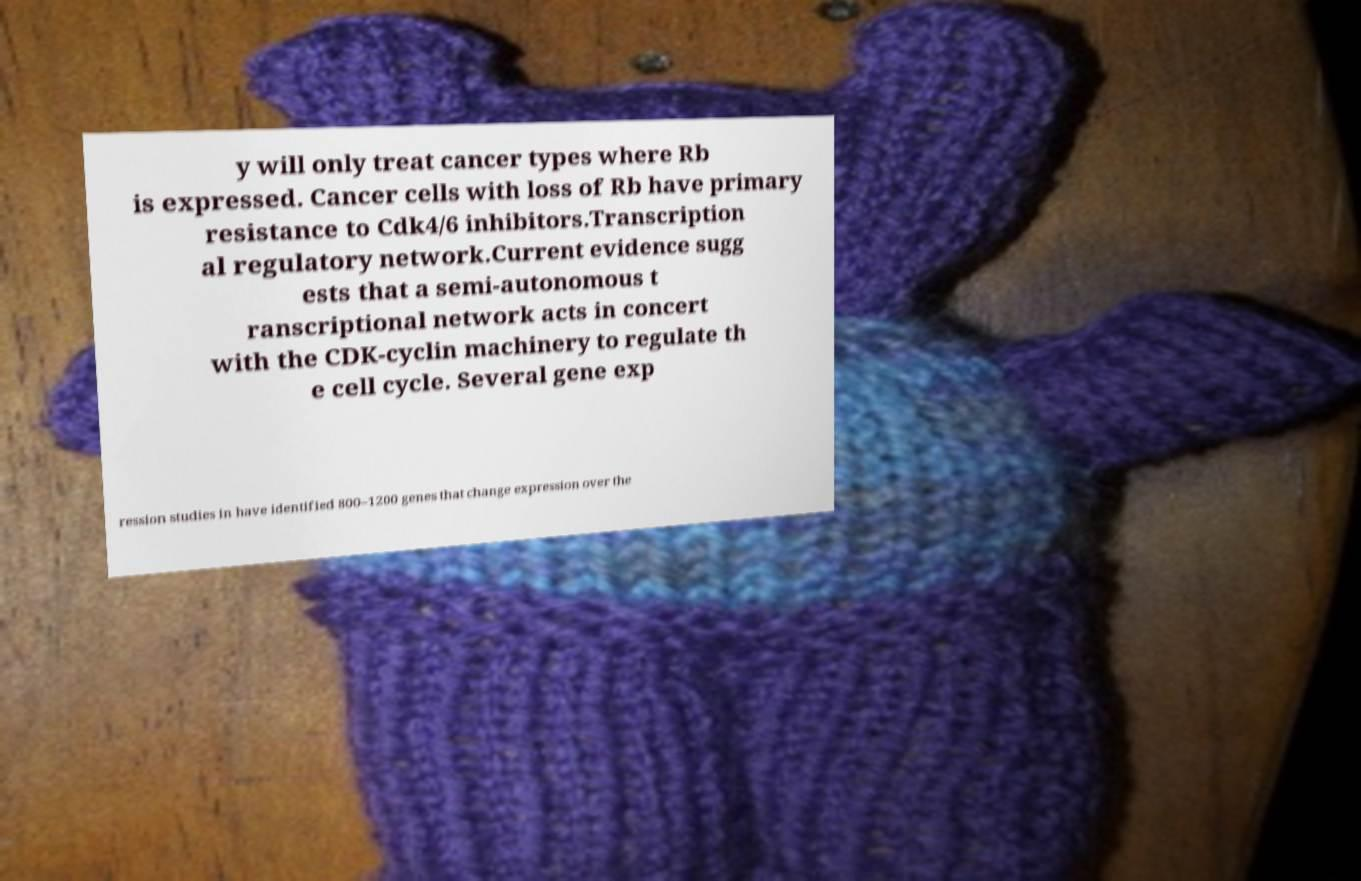Please identify and transcribe the text found in this image. y will only treat cancer types where Rb is expressed. Cancer cells with loss of Rb have primary resistance to Cdk4/6 inhibitors.Transcription al regulatory network.Current evidence sugg ests that a semi-autonomous t ranscriptional network acts in concert with the CDK-cyclin machinery to regulate th e cell cycle. Several gene exp ression studies in have identified 800–1200 genes that change expression over the 